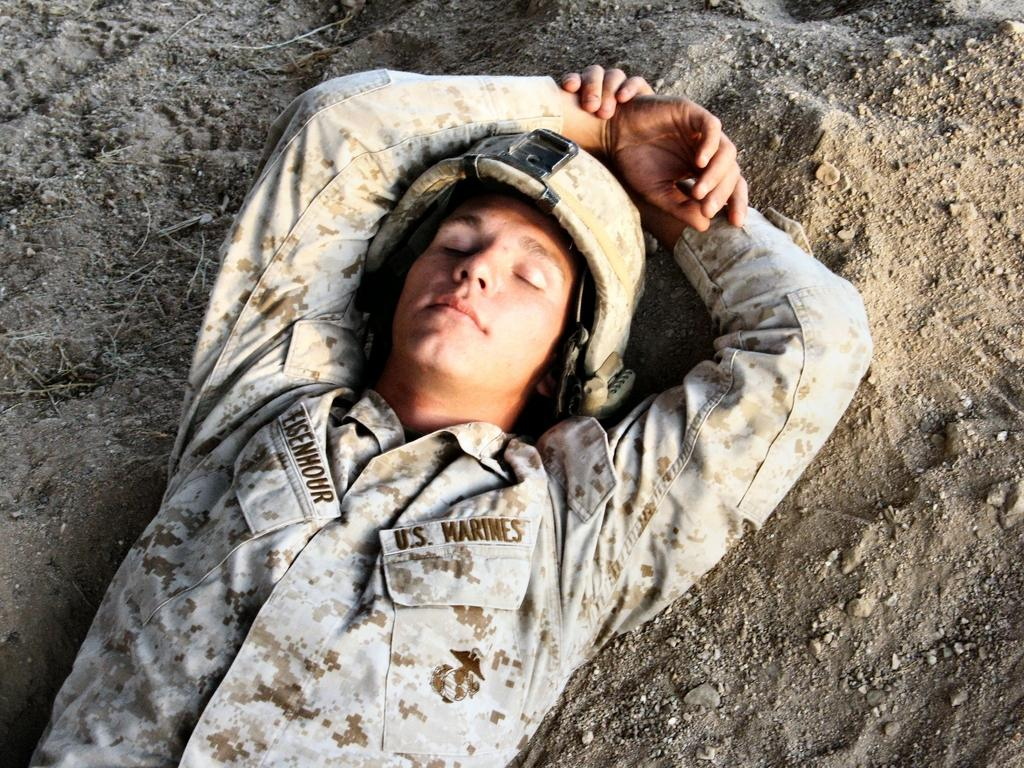Who is present in the image? There is a person in the image. What type of clothing is the person wearing? The person is wearing an army dress. What position is the person in? The person is laying on the ground. What type of headgear is the person wearing? The person is wearing a helmet. What type of light bulb is hanging above the person in the image? There is no light bulb present in the image. 